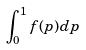<formula> <loc_0><loc_0><loc_500><loc_500>\int _ { 0 } ^ { 1 } f ( p ) d p</formula> 